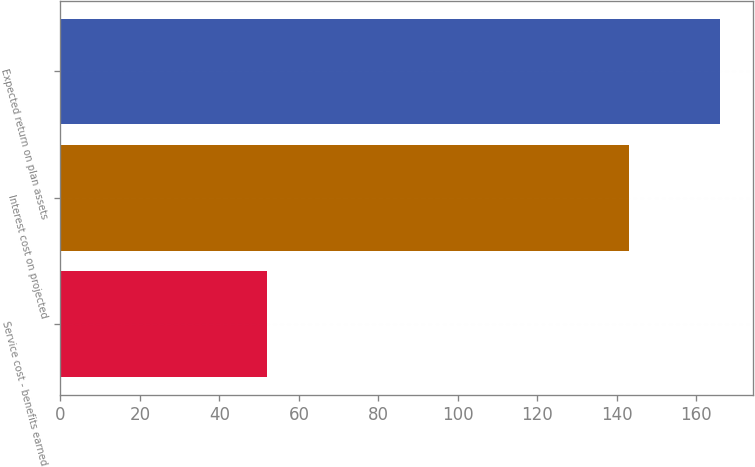<chart> <loc_0><loc_0><loc_500><loc_500><bar_chart><fcel>Service cost - benefits earned<fcel>Interest cost on projected<fcel>Expected return on plan assets<nl><fcel>52<fcel>143<fcel>166<nl></chart> 